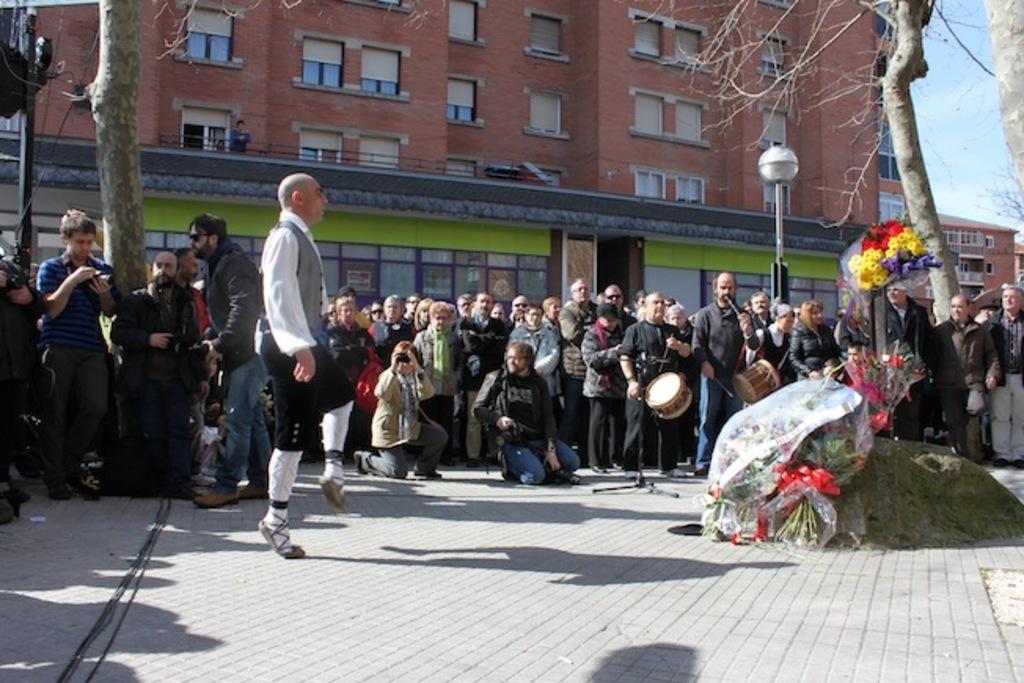Please provide a concise description of this image. In this image we can see a person dancing, in front of him there are flower bouquets and behind him there are a group of people, a few among them are playing musical instruments and some are taking photos, in the background there are buildings, trees and lights. 